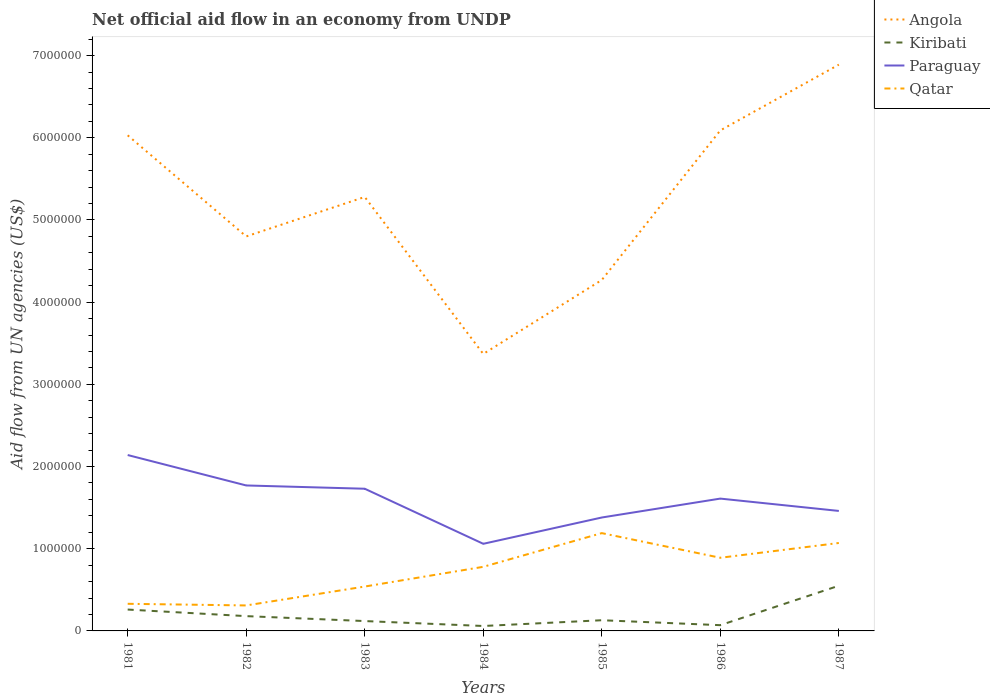Does the line corresponding to Qatar intersect with the line corresponding to Paraguay?
Provide a short and direct response. No. Across all years, what is the maximum net official aid flow in Angola?
Offer a very short reply. 3.37e+06. In which year was the net official aid flow in Qatar maximum?
Keep it short and to the point. 1982. What is the total net official aid flow in Qatar in the graph?
Your answer should be compact. -1.10e+05. What is the difference between the highest and the second highest net official aid flow in Paraguay?
Keep it short and to the point. 1.08e+06. Is the net official aid flow in Paraguay strictly greater than the net official aid flow in Kiribati over the years?
Your response must be concise. No. How many lines are there?
Offer a very short reply. 4. How many years are there in the graph?
Keep it short and to the point. 7. What is the difference between two consecutive major ticks on the Y-axis?
Ensure brevity in your answer.  1.00e+06. Does the graph contain any zero values?
Your answer should be very brief. No. What is the title of the graph?
Your answer should be compact. Net official aid flow in an economy from UNDP. Does "San Marino" appear as one of the legend labels in the graph?
Make the answer very short. No. What is the label or title of the Y-axis?
Provide a succinct answer. Aid flow from UN agencies (US$). What is the Aid flow from UN agencies (US$) of Angola in 1981?
Provide a short and direct response. 6.03e+06. What is the Aid flow from UN agencies (US$) in Paraguay in 1981?
Your answer should be compact. 2.14e+06. What is the Aid flow from UN agencies (US$) of Qatar in 1981?
Your answer should be very brief. 3.30e+05. What is the Aid flow from UN agencies (US$) of Angola in 1982?
Provide a succinct answer. 4.80e+06. What is the Aid flow from UN agencies (US$) in Kiribati in 1982?
Give a very brief answer. 1.80e+05. What is the Aid flow from UN agencies (US$) of Paraguay in 1982?
Your answer should be compact. 1.77e+06. What is the Aid flow from UN agencies (US$) of Angola in 1983?
Offer a terse response. 5.28e+06. What is the Aid flow from UN agencies (US$) in Paraguay in 1983?
Offer a very short reply. 1.73e+06. What is the Aid flow from UN agencies (US$) in Qatar in 1983?
Give a very brief answer. 5.40e+05. What is the Aid flow from UN agencies (US$) in Angola in 1984?
Ensure brevity in your answer.  3.37e+06. What is the Aid flow from UN agencies (US$) of Kiribati in 1984?
Give a very brief answer. 6.00e+04. What is the Aid flow from UN agencies (US$) of Paraguay in 1984?
Ensure brevity in your answer.  1.06e+06. What is the Aid flow from UN agencies (US$) in Qatar in 1984?
Give a very brief answer. 7.80e+05. What is the Aid flow from UN agencies (US$) of Angola in 1985?
Provide a succinct answer. 4.27e+06. What is the Aid flow from UN agencies (US$) of Kiribati in 1985?
Your answer should be very brief. 1.30e+05. What is the Aid flow from UN agencies (US$) in Paraguay in 1985?
Offer a terse response. 1.38e+06. What is the Aid flow from UN agencies (US$) in Qatar in 1985?
Offer a terse response. 1.19e+06. What is the Aid flow from UN agencies (US$) in Angola in 1986?
Give a very brief answer. 6.09e+06. What is the Aid flow from UN agencies (US$) of Kiribati in 1986?
Offer a very short reply. 7.00e+04. What is the Aid flow from UN agencies (US$) of Paraguay in 1986?
Your answer should be compact. 1.61e+06. What is the Aid flow from UN agencies (US$) in Qatar in 1986?
Provide a short and direct response. 8.90e+05. What is the Aid flow from UN agencies (US$) in Angola in 1987?
Ensure brevity in your answer.  6.89e+06. What is the Aid flow from UN agencies (US$) of Kiribati in 1987?
Offer a terse response. 5.50e+05. What is the Aid flow from UN agencies (US$) in Paraguay in 1987?
Keep it short and to the point. 1.46e+06. What is the Aid flow from UN agencies (US$) in Qatar in 1987?
Your answer should be very brief. 1.07e+06. Across all years, what is the maximum Aid flow from UN agencies (US$) in Angola?
Your response must be concise. 6.89e+06. Across all years, what is the maximum Aid flow from UN agencies (US$) of Paraguay?
Offer a terse response. 2.14e+06. Across all years, what is the maximum Aid flow from UN agencies (US$) of Qatar?
Offer a terse response. 1.19e+06. Across all years, what is the minimum Aid flow from UN agencies (US$) of Angola?
Provide a short and direct response. 3.37e+06. Across all years, what is the minimum Aid flow from UN agencies (US$) of Kiribati?
Your answer should be very brief. 6.00e+04. Across all years, what is the minimum Aid flow from UN agencies (US$) in Paraguay?
Keep it short and to the point. 1.06e+06. What is the total Aid flow from UN agencies (US$) in Angola in the graph?
Make the answer very short. 3.67e+07. What is the total Aid flow from UN agencies (US$) of Kiribati in the graph?
Offer a terse response. 1.37e+06. What is the total Aid flow from UN agencies (US$) of Paraguay in the graph?
Give a very brief answer. 1.12e+07. What is the total Aid flow from UN agencies (US$) of Qatar in the graph?
Make the answer very short. 5.11e+06. What is the difference between the Aid flow from UN agencies (US$) of Angola in 1981 and that in 1982?
Provide a succinct answer. 1.23e+06. What is the difference between the Aid flow from UN agencies (US$) in Angola in 1981 and that in 1983?
Keep it short and to the point. 7.50e+05. What is the difference between the Aid flow from UN agencies (US$) of Paraguay in 1981 and that in 1983?
Offer a very short reply. 4.10e+05. What is the difference between the Aid flow from UN agencies (US$) of Qatar in 1981 and that in 1983?
Provide a short and direct response. -2.10e+05. What is the difference between the Aid flow from UN agencies (US$) of Angola in 1981 and that in 1984?
Offer a terse response. 2.66e+06. What is the difference between the Aid flow from UN agencies (US$) in Paraguay in 1981 and that in 1984?
Provide a short and direct response. 1.08e+06. What is the difference between the Aid flow from UN agencies (US$) in Qatar in 1981 and that in 1984?
Your answer should be compact. -4.50e+05. What is the difference between the Aid flow from UN agencies (US$) in Angola in 1981 and that in 1985?
Your response must be concise. 1.76e+06. What is the difference between the Aid flow from UN agencies (US$) in Kiribati in 1981 and that in 1985?
Make the answer very short. 1.30e+05. What is the difference between the Aid flow from UN agencies (US$) of Paraguay in 1981 and that in 1985?
Your response must be concise. 7.60e+05. What is the difference between the Aid flow from UN agencies (US$) of Qatar in 1981 and that in 1985?
Your answer should be compact. -8.60e+05. What is the difference between the Aid flow from UN agencies (US$) in Angola in 1981 and that in 1986?
Ensure brevity in your answer.  -6.00e+04. What is the difference between the Aid flow from UN agencies (US$) in Kiribati in 1981 and that in 1986?
Ensure brevity in your answer.  1.90e+05. What is the difference between the Aid flow from UN agencies (US$) in Paraguay in 1981 and that in 1986?
Make the answer very short. 5.30e+05. What is the difference between the Aid flow from UN agencies (US$) of Qatar in 1981 and that in 1986?
Keep it short and to the point. -5.60e+05. What is the difference between the Aid flow from UN agencies (US$) of Angola in 1981 and that in 1987?
Ensure brevity in your answer.  -8.60e+05. What is the difference between the Aid flow from UN agencies (US$) of Kiribati in 1981 and that in 1987?
Provide a succinct answer. -2.90e+05. What is the difference between the Aid flow from UN agencies (US$) in Paraguay in 1981 and that in 1987?
Offer a terse response. 6.80e+05. What is the difference between the Aid flow from UN agencies (US$) in Qatar in 1981 and that in 1987?
Give a very brief answer. -7.40e+05. What is the difference between the Aid flow from UN agencies (US$) in Angola in 1982 and that in 1983?
Keep it short and to the point. -4.80e+05. What is the difference between the Aid flow from UN agencies (US$) of Paraguay in 1982 and that in 1983?
Make the answer very short. 4.00e+04. What is the difference between the Aid flow from UN agencies (US$) in Qatar in 1982 and that in 1983?
Offer a very short reply. -2.30e+05. What is the difference between the Aid flow from UN agencies (US$) of Angola in 1982 and that in 1984?
Keep it short and to the point. 1.43e+06. What is the difference between the Aid flow from UN agencies (US$) in Kiribati in 1982 and that in 1984?
Your answer should be very brief. 1.20e+05. What is the difference between the Aid flow from UN agencies (US$) of Paraguay in 1982 and that in 1984?
Offer a very short reply. 7.10e+05. What is the difference between the Aid flow from UN agencies (US$) in Qatar in 1982 and that in 1984?
Ensure brevity in your answer.  -4.70e+05. What is the difference between the Aid flow from UN agencies (US$) of Angola in 1982 and that in 1985?
Keep it short and to the point. 5.30e+05. What is the difference between the Aid flow from UN agencies (US$) of Qatar in 1982 and that in 1985?
Your answer should be very brief. -8.80e+05. What is the difference between the Aid flow from UN agencies (US$) of Angola in 1982 and that in 1986?
Your response must be concise. -1.29e+06. What is the difference between the Aid flow from UN agencies (US$) in Kiribati in 1982 and that in 1986?
Provide a short and direct response. 1.10e+05. What is the difference between the Aid flow from UN agencies (US$) of Qatar in 1982 and that in 1986?
Your answer should be compact. -5.80e+05. What is the difference between the Aid flow from UN agencies (US$) of Angola in 1982 and that in 1987?
Give a very brief answer. -2.09e+06. What is the difference between the Aid flow from UN agencies (US$) of Kiribati in 1982 and that in 1987?
Ensure brevity in your answer.  -3.70e+05. What is the difference between the Aid flow from UN agencies (US$) in Paraguay in 1982 and that in 1987?
Your answer should be compact. 3.10e+05. What is the difference between the Aid flow from UN agencies (US$) in Qatar in 1982 and that in 1987?
Make the answer very short. -7.60e+05. What is the difference between the Aid flow from UN agencies (US$) in Angola in 1983 and that in 1984?
Keep it short and to the point. 1.91e+06. What is the difference between the Aid flow from UN agencies (US$) in Paraguay in 1983 and that in 1984?
Your answer should be very brief. 6.70e+05. What is the difference between the Aid flow from UN agencies (US$) of Angola in 1983 and that in 1985?
Your answer should be compact. 1.01e+06. What is the difference between the Aid flow from UN agencies (US$) in Paraguay in 1983 and that in 1985?
Offer a terse response. 3.50e+05. What is the difference between the Aid flow from UN agencies (US$) of Qatar in 1983 and that in 1985?
Ensure brevity in your answer.  -6.50e+05. What is the difference between the Aid flow from UN agencies (US$) of Angola in 1983 and that in 1986?
Provide a succinct answer. -8.10e+05. What is the difference between the Aid flow from UN agencies (US$) in Kiribati in 1983 and that in 1986?
Make the answer very short. 5.00e+04. What is the difference between the Aid flow from UN agencies (US$) in Paraguay in 1983 and that in 1986?
Your answer should be very brief. 1.20e+05. What is the difference between the Aid flow from UN agencies (US$) in Qatar in 1983 and that in 1986?
Your answer should be compact. -3.50e+05. What is the difference between the Aid flow from UN agencies (US$) in Angola in 1983 and that in 1987?
Ensure brevity in your answer.  -1.61e+06. What is the difference between the Aid flow from UN agencies (US$) in Kiribati in 1983 and that in 1987?
Make the answer very short. -4.30e+05. What is the difference between the Aid flow from UN agencies (US$) of Qatar in 1983 and that in 1987?
Provide a succinct answer. -5.30e+05. What is the difference between the Aid flow from UN agencies (US$) in Angola in 1984 and that in 1985?
Give a very brief answer. -9.00e+05. What is the difference between the Aid flow from UN agencies (US$) in Kiribati in 1984 and that in 1985?
Offer a terse response. -7.00e+04. What is the difference between the Aid flow from UN agencies (US$) of Paraguay in 1984 and that in 1985?
Your response must be concise. -3.20e+05. What is the difference between the Aid flow from UN agencies (US$) in Qatar in 1984 and that in 1985?
Your answer should be very brief. -4.10e+05. What is the difference between the Aid flow from UN agencies (US$) in Angola in 1984 and that in 1986?
Ensure brevity in your answer.  -2.72e+06. What is the difference between the Aid flow from UN agencies (US$) in Kiribati in 1984 and that in 1986?
Your answer should be compact. -10000. What is the difference between the Aid flow from UN agencies (US$) of Paraguay in 1984 and that in 1986?
Provide a succinct answer. -5.50e+05. What is the difference between the Aid flow from UN agencies (US$) in Qatar in 1984 and that in 1986?
Offer a terse response. -1.10e+05. What is the difference between the Aid flow from UN agencies (US$) of Angola in 1984 and that in 1987?
Your answer should be compact. -3.52e+06. What is the difference between the Aid flow from UN agencies (US$) of Kiribati in 1984 and that in 1987?
Your answer should be compact. -4.90e+05. What is the difference between the Aid flow from UN agencies (US$) of Paraguay in 1984 and that in 1987?
Make the answer very short. -4.00e+05. What is the difference between the Aid flow from UN agencies (US$) in Qatar in 1984 and that in 1987?
Offer a very short reply. -2.90e+05. What is the difference between the Aid flow from UN agencies (US$) of Angola in 1985 and that in 1986?
Provide a short and direct response. -1.82e+06. What is the difference between the Aid flow from UN agencies (US$) in Angola in 1985 and that in 1987?
Your response must be concise. -2.62e+06. What is the difference between the Aid flow from UN agencies (US$) in Kiribati in 1985 and that in 1987?
Keep it short and to the point. -4.20e+05. What is the difference between the Aid flow from UN agencies (US$) of Paraguay in 1985 and that in 1987?
Offer a terse response. -8.00e+04. What is the difference between the Aid flow from UN agencies (US$) in Angola in 1986 and that in 1987?
Offer a very short reply. -8.00e+05. What is the difference between the Aid flow from UN agencies (US$) in Kiribati in 1986 and that in 1987?
Keep it short and to the point. -4.80e+05. What is the difference between the Aid flow from UN agencies (US$) of Angola in 1981 and the Aid flow from UN agencies (US$) of Kiribati in 1982?
Keep it short and to the point. 5.85e+06. What is the difference between the Aid flow from UN agencies (US$) of Angola in 1981 and the Aid flow from UN agencies (US$) of Paraguay in 1982?
Offer a terse response. 4.26e+06. What is the difference between the Aid flow from UN agencies (US$) in Angola in 1981 and the Aid flow from UN agencies (US$) in Qatar in 1982?
Keep it short and to the point. 5.72e+06. What is the difference between the Aid flow from UN agencies (US$) of Kiribati in 1981 and the Aid flow from UN agencies (US$) of Paraguay in 1982?
Your response must be concise. -1.51e+06. What is the difference between the Aid flow from UN agencies (US$) of Kiribati in 1981 and the Aid flow from UN agencies (US$) of Qatar in 1982?
Keep it short and to the point. -5.00e+04. What is the difference between the Aid flow from UN agencies (US$) in Paraguay in 1981 and the Aid flow from UN agencies (US$) in Qatar in 1982?
Offer a very short reply. 1.83e+06. What is the difference between the Aid flow from UN agencies (US$) in Angola in 1981 and the Aid flow from UN agencies (US$) in Kiribati in 1983?
Give a very brief answer. 5.91e+06. What is the difference between the Aid flow from UN agencies (US$) of Angola in 1981 and the Aid flow from UN agencies (US$) of Paraguay in 1983?
Keep it short and to the point. 4.30e+06. What is the difference between the Aid flow from UN agencies (US$) of Angola in 1981 and the Aid flow from UN agencies (US$) of Qatar in 1983?
Ensure brevity in your answer.  5.49e+06. What is the difference between the Aid flow from UN agencies (US$) of Kiribati in 1981 and the Aid flow from UN agencies (US$) of Paraguay in 1983?
Your answer should be very brief. -1.47e+06. What is the difference between the Aid flow from UN agencies (US$) of Kiribati in 1981 and the Aid flow from UN agencies (US$) of Qatar in 1983?
Provide a succinct answer. -2.80e+05. What is the difference between the Aid flow from UN agencies (US$) in Paraguay in 1981 and the Aid flow from UN agencies (US$) in Qatar in 1983?
Your answer should be compact. 1.60e+06. What is the difference between the Aid flow from UN agencies (US$) in Angola in 1981 and the Aid flow from UN agencies (US$) in Kiribati in 1984?
Your answer should be compact. 5.97e+06. What is the difference between the Aid flow from UN agencies (US$) of Angola in 1981 and the Aid flow from UN agencies (US$) of Paraguay in 1984?
Your answer should be very brief. 4.97e+06. What is the difference between the Aid flow from UN agencies (US$) of Angola in 1981 and the Aid flow from UN agencies (US$) of Qatar in 1984?
Make the answer very short. 5.25e+06. What is the difference between the Aid flow from UN agencies (US$) of Kiribati in 1981 and the Aid flow from UN agencies (US$) of Paraguay in 1984?
Keep it short and to the point. -8.00e+05. What is the difference between the Aid flow from UN agencies (US$) of Kiribati in 1981 and the Aid flow from UN agencies (US$) of Qatar in 1984?
Ensure brevity in your answer.  -5.20e+05. What is the difference between the Aid flow from UN agencies (US$) in Paraguay in 1981 and the Aid flow from UN agencies (US$) in Qatar in 1984?
Your answer should be very brief. 1.36e+06. What is the difference between the Aid flow from UN agencies (US$) in Angola in 1981 and the Aid flow from UN agencies (US$) in Kiribati in 1985?
Your answer should be very brief. 5.90e+06. What is the difference between the Aid flow from UN agencies (US$) of Angola in 1981 and the Aid flow from UN agencies (US$) of Paraguay in 1985?
Provide a short and direct response. 4.65e+06. What is the difference between the Aid flow from UN agencies (US$) in Angola in 1981 and the Aid flow from UN agencies (US$) in Qatar in 1985?
Your response must be concise. 4.84e+06. What is the difference between the Aid flow from UN agencies (US$) of Kiribati in 1981 and the Aid flow from UN agencies (US$) of Paraguay in 1985?
Offer a terse response. -1.12e+06. What is the difference between the Aid flow from UN agencies (US$) of Kiribati in 1981 and the Aid flow from UN agencies (US$) of Qatar in 1985?
Offer a very short reply. -9.30e+05. What is the difference between the Aid flow from UN agencies (US$) of Paraguay in 1981 and the Aid flow from UN agencies (US$) of Qatar in 1985?
Your answer should be very brief. 9.50e+05. What is the difference between the Aid flow from UN agencies (US$) of Angola in 1981 and the Aid flow from UN agencies (US$) of Kiribati in 1986?
Your answer should be compact. 5.96e+06. What is the difference between the Aid flow from UN agencies (US$) in Angola in 1981 and the Aid flow from UN agencies (US$) in Paraguay in 1986?
Provide a succinct answer. 4.42e+06. What is the difference between the Aid flow from UN agencies (US$) of Angola in 1981 and the Aid flow from UN agencies (US$) of Qatar in 1986?
Provide a short and direct response. 5.14e+06. What is the difference between the Aid flow from UN agencies (US$) in Kiribati in 1981 and the Aid flow from UN agencies (US$) in Paraguay in 1986?
Your answer should be very brief. -1.35e+06. What is the difference between the Aid flow from UN agencies (US$) of Kiribati in 1981 and the Aid flow from UN agencies (US$) of Qatar in 1986?
Make the answer very short. -6.30e+05. What is the difference between the Aid flow from UN agencies (US$) in Paraguay in 1981 and the Aid flow from UN agencies (US$) in Qatar in 1986?
Provide a short and direct response. 1.25e+06. What is the difference between the Aid flow from UN agencies (US$) in Angola in 1981 and the Aid flow from UN agencies (US$) in Kiribati in 1987?
Your answer should be compact. 5.48e+06. What is the difference between the Aid flow from UN agencies (US$) in Angola in 1981 and the Aid flow from UN agencies (US$) in Paraguay in 1987?
Provide a short and direct response. 4.57e+06. What is the difference between the Aid flow from UN agencies (US$) of Angola in 1981 and the Aid flow from UN agencies (US$) of Qatar in 1987?
Give a very brief answer. 4.96e+06. What is the difference between the Aid flow from UN agencies (US$) in Kiribati in 1981 and the Aid flow from UN agencies (US$) in Paraguay in 1987?
Offer a terse response. -1.20e+06. What is the difference between the Aid flow from UN agencies (US$) in Kiribati in 1981 and the Aid flow from UN agencies (US$) in Qatar in 1987?
Offer a terse response. -8.10e+05. What is the difference between the Aid flow from UN agencies (US$) of Paraguay in 1981 and the Aid flow from UN agencies (US$) of Qatar in 1987?
Offer a very short reply. 1.07e+06. What is the difference between the Aid flow from UN agencies (US$) of Angola in 1982 and the Aid flow from UN agencies (US$) of Kiribati in 1983?
Offer a terse response. 4.68e+06. What is the difference between the Aid flow from UN agencies (US$) of Angola in 1982 and the Aid flow from UN agencies (US$) of Paraguay in 1983?
Your answer should be compact. 3.07e+06. What is the difference between the Aid flow from UN agencies (US$) of Angola in 1982 and the Aid flow from UN agencies (US$) of Qatar in 1983?
Provide a succinct answer. 4.26e+06. What is the difference between the Aid flow from UN agencies (US$) in Kiribati in 1982 and the Aid flow from UN agencies (US$) in Paraguay in 1983?
Ensure brevity in your answer.  -1.55e+06. What is the difference between the Aid flow from UN agencies (US$) of Kiribati in 1982 and the Aid flow from UN agencies (US$) of Qatar in 1983?
Provide a succinct answer. -3.60e+05. What is the difference between the Aid flow from UN agencies (US$) of Paraguay in 1982 and the Aid flow from UN agencies (US$) of Qatar in 1983?
Ensure brevity in your answer.  1.23e+06. What is the difference between the Aid flow from UN agencies (US$) in Angola in 1982 and the Aid flow from UN agencies (US$) in Kiribati in 1984?
Provide a short and direct response. 4.74e+06. What is the difference between the Aid flow from UN agencies (US$) in Angola in 1982 and the Aid flow from UN agencies (US$) in Paraguay in 1984?
Your answer should be very brief. 3.74e+06. What is the difference between the Aid flow from UN agencies (US$) of Angola in 1982 and the Aid flow from UN agencies (US$) of Qatar in 1984?
Make the answer very short. 4.02e+06. What is the difference between the Aid flow from UN agencies (US$) of Kiribati in 1982 and the Aid flow from UN agencies (US$) of Paraguay in 1984?
Offer a terse response. -8.80e+05. What is the difference between the Aid flow from UN agencies (US$) in Kiribati in 1982 and the Aid flow from UN agencies (US$) in Qatar in 1984?
Provide a succinct answer. -6.00e+05. What is the difference between the Aid flow from UN agencies (US$) of Paraguay in 1982 and the Aid flow from UN agencies (US$) of Qatar in 1984?
Keep it short and to the point. 9.90e+05. What is the difference between the Aid flow from UN agencies (US$) of Angola in 1982 and the Aid flow from UN agencies (US$) of Kiribati in 1985?
Offer a very short reply. 4.67e+06. What is the difference between the Aid flow from UN agencies (US$) in Angola in 1982 and the Aid flow from UN agencies (US$) in Paraguay in 1985?
Provide a short and direct response. 3.42e+06. What is the difference between the Aid flow from UN agencies (US$) in Angola in 1982 and the Aid flow from UN agencies (US$) in Qatar in 1985?
Give a very brief answer. 3.61e+06. What is the difference between the Aid flow from UN agencies (US$) in Kiribati in 1982 and the Aid flow from UN agencies (US$) in Paraguay in 1985?
Offer a very short reply. -1.20e+06. What is the difference between the Aid flow from UN agencies (US$) in Kiribati in 1982 and the Aid flow from UN agencies (US$) in Qatar in 1985?
Your answer should be compact. -1.01e+06. What is the difference between the Aid flow from UN agencies (US$) of Paraguay in 1982 and the Aid flow from UN agencies (US$) of Qatar in 1985?
Your response must be concise. 5.80e+05. What is the difference between the Aid flow from UN agencies (US$) in Angola in 1982 and the Aid flow from UN agencies (US$) in Kiribati in 1986?
Give a very brief answer. 4.73e+06. What is the difference between the Aid flow from UN agencies (US$) of Angola in 1982 and the Aid flow from UN agencies (US$) of Paraguay in 1986?
Keep it short and to the point. 3.19e+06. What is the difference between the Aid flow from UN agencies (US$) in Angola in 1982 and the Aid flow from UN agencies (US$) in Qatar in 1986?
Your response must be concise. 3.91e+06. What is the difference between the Aid flow from UN agencies (US$) in Kiribati in 1982 and the Aid flow from UN agencies (US$) in Paraguay in 1986?
Provide a short and direct response. -1.43e+06. What is the difference between the Aid flow from UN agencies (US$) of Kiribati in 1982 and the Aid flow from UN agencies (US$) of Qatar in 1986?
Offer a terse response. -7.10e+05. What is the difference between the Aid flow from UN agencies (US$) in Paraguay in 1982 and the Aid flow from UN agencies (US$) in Qatar in 1986?
Ensure brevity in your answer.  8.80e+05. What is the difference between the Aid flow from UN agencies (US$) in Angola in 1982 and the Aid flow from UN agencies (US$) in Kiribati in 1987?
Keep it short and to the point. 4.25e+06. What is the difference between the Aid flow from UN agencies (US$) in Angola in 1982 and the Aid flow from UN agencies (US$) in Paraguay in 1987?
Your response must be concise. 3.34e+06. What is the difference between the Aid flow from UN agencies (US$) of Angola in 1982 and the Aid flow from UN agencies (US$) of Qatar in 1987?
Provide a succinct answer. 3.73e+06. What is the difference between the Aid flow from UN agencies (US$) in Kiribati in 1982 and the Aid flow from UN agencies (US$) in Paraguay in 1987?
Offer a very short reply. -1.28e+06. What is the difference between the Aid flow from UN agencies (US$) of Kiribati in 1982 and the Aid flow from UN agencies (US$) of Qatar in 1987?
Ensure brevity in your answer.  -8.90e+05. What is the difference between the Aid flow from UN agencies (US$) in Angola in 1983 and the Aid flow from UN agencies (US$) in Kiribati in 1984?
Give a very brief answer. 5.22e+06. What is the difference between the Aid flow from UN agencies (US$) of Angola in 1983 and the Aid flow from UN agencies (US$) of Paraguay in 1984?
Provide a succinct answer. 4.22e+06. What is the difference between the Aid flow from UN agencies (US$) in Angola in 1983 and the Aid flow from UN agencies (US$) in Qatar in 1984?
Provide a succinct answer. 4.50e+06. What is the difference between the Aid flow from UN agencies (US$) of Kiribati in 1983 and the Aid flow from UN agencies (US$) of Paraguay in 1984?
Provide a short and direct response. -9.40e+05. What is the difference between the Aid flow from UN agencies (US$) in Kiribati in 1983 and the Aid flow from UN agencies (US$) in Qatar in 1984?
Ensure brevity in your answer.  -6.60e+05. What is the difference between the Aid flow from UN agencies (US$) of Paraguay in 1983 and the Aid flow from UN agencies (US$) of Qatar in 1984?
Give a very brief answer. 9.50e+05. What is the difference between the Aid flow from UN agencies (US$) of Angola in 1983 and the Aid flow from UN agencies (US$) of Kiribati in 1985?
Offer a very short reply. 5.15e+06. What is the difference between the Aid flow from UN agencies (US$) of Angola in 1983 and the Aid flow from UN agencies (US$) of Paraguay in 1985?
Offer a very short reply. 3.90e+06. What is the difference between the Aid flow from UN agencies (US$) in Angola in 1983 and the Aid flow from UN agencies (US$) in Qatar in 1985?
Offer a terse response. 4.09e+06. What is the difference between the Aid flow from UN agencies (US$) of Kiribati in 1983 and the Aid flow from UN agencies (US$) of Paraguay in 1985?
Your answer should be compact. -1.26e+06. What is the difference between the Aid flow from UN agencies (US$) of Kiribati in 1983 and the Aid flow from UN agencies (US$) of Qatar in 1985?
Your response must be concise. -1.07e+06. What is the difference between the Aid flow from UN agencies (US$) in Paraguay in 1983 and the Aid flow from UN agencies (US$) in Qatar in 1985?
Provide a succinct answer. 5.40e+05. What is the difference between the Aid flow from UN agencies (US$) in Angola in 1983 and the Aid flow from UN agencies (US$) in Kiribati in 1986?
Provide a succinct answer. 5.21e+06. What is the difference between the Aid flow from UN agencies (US$) of Angola in 1983 and the Aid flow from UN agencies (US$) of Paraguay in 1986?
Make the answer very short. 3.67e+06. What is the difference between the Aid flow from UN agencies (US$) of Angola in 1983 and the Aid flow from UN agencies (US$) of Qatar in 1986?
Your answer should be compact. 4.39e+06. What is the difference between the Aid flow from UN agencies (US$) in Kiribati in 1983 and the Aid flow from UN agencies (US$) in Paraguay in 1986?
Your answer should be compact. -1.49e+06. What is the difference between the Aid flow from UN agencies (US$) of Kiribati in 1983 and the Aid flow from UN agencies (US$) of Qatar in 1986?
Offer a terse response. -7.70e+05. What is the difference between the Aid flow from UN agencies (US$) in Paraguay in 1983 and the Aid flow from UN agencies (US$) in Qatar in 1986?
Keep it short and to the point. 8.40e+05. What is the difference between the Aid flow from UN agencies (US$) in Angola in 1983 and the Aid flow from UN agencies (US$) in Kiribati in 1987?
Your response must be concise. 4.73e+06. What is the difference between the Aid flow from UN agencies (US$) of Angola in 1983 and the Aid flow from UN agencies (US$) of Paraguay in 1987?
Give a very brief answer. 3.82e+06. What is the difference between the Aid flow from UN agencies (US$) of Angola in 1983 and the Aid flow from UN agencies (US$) of Qatar in 1987?
Offer a very short reply. 4.21e+06. What is the difference between the Aid flow from UN agencies (US$) in Kiribati in 1983 and the Aid flow from UN agencies (US$) in Paraguay in 1987?
Give a very brief answer. -1.34e+06. What is the difference between the Aid flow from UN agencies (US$) of Kiribati in 1983 and the Aid flow from UN agencies (US$) of Qatar in 1987?
Ensure brevity in your answer.  -9.50e+05. What is the difference between the Aid flow from UN agencies (US$) in Paraguay in 1983 and the Aid flow from UN agencies (US$) in Qatar in 1987?
Keep it short and to the point. 6.60e+05. What is the difference between the Aid flow from UN agencies (US$) of Angola in 1984 and the Aid flow from UN agencies (US$) of Kiribati in 1985?
Your response must be concise. 3.24e+06. What is the difference between the Aid flow from UN agencies (US$) of Angola in 1984 and the Aid flow from UN agencies (US$) of Paraguay in 1985?
Provide a succinct answer. 1.99e+06. What is the difference between the Aid flow from UN agencies (US$) in Angola in 1984 and the Aid flow from UN agencies (US$) in Qatar in 1985?
Offer a very short reply. 2.18e+06. What is the difference between the Aid flow from UN agencies (US$) of Kiribati in 1984 and the Aid flow from UN agencies (US$) of Paraguay in 1985?
Provide a short and direct response. -1.32e+06. What is the difference between the Aid flow from UN agencies (US$) in Kiribati in 1984 and the Aid flow from UN agencies (US$) in Qatar in 1985?
Provide a succinct answer. -1.13e+06. What is the difference between the Aid flow from UN agencies (US$) in Angola in 1984 and the Aid flow from UN agencies (US$) in Kiribati in 1986?
Keep it short and to the point. 3.30e+06. What is the difference between the Aid flow from UN agencies (US$) of Angola in 1984 and the Aid flow from UN agencies (US$) of Paraguay in 1986?
Provide a succinct answer. 1.76e+06. What is the difference between the Aid flow from UN agencies (US$) of Angola in 1984 and the Aid flow from UN agencies (US$) of Qatar in 1986?
Offer a very short reply. 2.48e+06. What is the difference between the Aid flow from UN agencies (US$) of Kiribati in 1984 and the Aid flow from UN agencies (US$) of Paraguay in 1986?
Your response must be concise. -1.55e+06. What is the difference between the Aid flow from UN agencies (US$) of Kiribati in 1984 and the Aid flow from UN agencies (US$) of Qatar in 1986?
Provide a short and direct response. -8.30e+05. What is the difference between the Aid flow from UN agencies (US$) of Angola in 1984 and the Aid flow from UN agencies (US$) of Kiribati in 1987?
Ensure brevity in your answer.  2.82e+06. What is the difference between the Aid flow from UN agencies (US$) of Angola in 1984 and the Aid flow from UN agencies (US$) of Paraguay in 1987?
Offer a very short reply. 1.91e+06. What is the difference between the Aid flow from UN agencies (US$) in Angola in 1984 and the Aid flow from UN agencies (US$) in Qatar in 1987?
Your response must be concise. 2.30e+06. What is the difference between the Aid flow from UN agencies (US$) in Kiribati in 1984 and the Aid flow from UN agencies (US$) in Paraguay in 1987?
Make the answer very short. -1.40e+06. What is the difference between the Aid flow from UN agencies (US$) of Kiribati in 1984 and the Aid flow from UN agencies (US$) of Qatar in 1987?
Provide a succinct answer. -1.01e+06. What is the difference between the Aid flow from UN agencies (US$) in Paraguay in 1984 and the Aid flow from UN agencies (US$) in Qatar in 1987?
Give a very brief answer. -10000. What is the difference between the Aid flow from UN agencies (US$) in Angola in 1985 and the Aid flow from UN agencies (US$) in Kiribati in 1986?
Keep it short and to the point. 4.20e+06. What is the difference between the Aid flow from UN agencies (US$) of Angola in 1985 and the Aid flow from UN agencies (US$) of Paraguay in 1986?
Your answer should be very brief. 2.66e+06. What is the difference between the Aid flow from UN agencies (US$) in Angola in 1985 and the Aid flow from UN agencies (US$) in Qatar in 1986?
Your response must be concise. 3.38e+06. What is the difference between the Aid flow from UN agencies (US$) in Kiribati in 1985 and the Aid flow from UN agencies (US$) in Paraguay in 1986?
Your response must be concise. -1.48e+06. What is the difference between the Aid flow from UN agencies (US$) in Kiribati in 1985 and the Aid flow from UN agencies (US$) in Qatar in 1986?
Your answer should be compact. -7.60e+05. What is the difference between the Aid flow from UN agencies (US$) of Paraguay in 1985 and the Aid flow from UN agencies (US$) of Qatar in 1986?
Provide a short and direct response. 4.90e+05. What is the difference between the Aid flow from UN agencies (US$) of Angola in 1985 and the Aid flow from UN agencies (US$) of Kiribati in 1987?
Provide a succinct answer. 3.72e+06. What is the difference between the Aid flow from UN agencies (US$) in Angola in 1985 and the Aid flow from UN agencies (US$) in Paraguay in 1987?
Offer a very short reply. 2.81e+06. What is the difference between the Aid flow from UN agencies (US$) of Angola in 1985 and the Aid flow from UN agencies (US$) of Qatar in 1987?
Your response must be concise. 3.20e+06. What is the difference between the Aid flow from UN agencies (US$) of Kiribati in 1985 and the Aid flow from UN agencies (US$) of Paraguay in 1987?
Your answer should be compact. -1.33e+06. What is the difference between the Aid flow from UN agencies (US$) of Kiribati in 1985 and the Aid flow from UN agencies (US$) of Qatar in 1987?
Keep it short and to the point. -9.40e+05. What is the difference between the Aid flow from UN agencies (US$) of Paraguay in 1985 and the Aid flow from UN agencies (US$) of Qatar in 1987?
Keep it short and to the point. 3.10e+05. What is the difference between the Aid flow from UN agencies (US$) of Angola in 1986 and the Aid flow from UN agencies (US$) of Kiribati in 1987?
Your response must be concise. 5.54e+06. What is the difference between the Aid flow from UN agencies (US$) in Angola in 1986 and the Aid flow from UN agencies (US$) in Paraguay in 1987?
Keep it short and to the point. 4.63e+06. What is the difference between the Aid flow from UN agencies (US$) of Angola in 1986 and the Aid flow from UN agencies (US$) of Qatar in 1987?
Provide a short and direct response. 5.02e+06. What is the difference between the Aid flow from UN agencies (US$) of Kiribati in 1986 and the Aid flow from UN agencies (US$) of Paraguay in 1987?
Your answer should be compact. -1.39e+06. What is the difference between the Aid flow from UN agencies (US$) of Paraguay in 1986 and the Aid flow from UN agencies (US$) of Qatar in 1987?
Keep it short and to the point. 5.40e+05. What is the average Aid flow from UN agencies (US$) in Angola per year?
Your response must be concise. 5.25e+06. What is the average Aid flow from UN agencies (US$) of Kiribati per year?
Your answer should be compact. 1.96e+05. What is the average Aid flow from UN agencies (US$) of Paraguay per year?
Your answer should be very brief. 1.59e+06. What is the average Aid flow from UN agencies (US$) in Qatar per year?
Give a very brief answer. 7.30e+05. In the year 1981, what is the difference between the Aid flow from UN agencies (US$) in Angola and Aid flow from UN agencies (US$) in Kiribati?
Ensure brevity in your answer.  5.77e+06. In the year 1981, what is the difference between the Aid flow from UN agencies (US$) in Angola and Aid flow from UN agencies (US$) in Paraguay?
Your answer should be compact. 3.89e+06. In the year 1981, what is the difference between the Aid flow from UN agencies (US$) of Angola and Aid flow from UN agencies (US$) of Qatar?
Your response must be concise. 5.70e+06. In the year 1981, what is the difference between the Aid flow from UN agencies (US$) in Kiribati and Aid flow from UN agencies (US$) in Paraguay?
Provide a succinct answer. -1.88e+06. In the year 1981, what is the difference between the Aid flow from UN agencies (US$) in Paraguay and Aid flow from UN agencies (US$) in Qatar?
Provide a short and direct response. 1.81e+06. In the year 1982, what is the difference between the Aid flow from UN agencies (US$) in Angola and Aid flow from UN agencies (US$) in Kiribati?
Offer a very short reply. 4.62e+06. In the year 1982, what is the difference between the Aid flow from UN agencies (US$) in Angola and Aid flow from UN agencies (US$) in Paraguay?
Offer a terse response. 3.03e+06. In the year 1982, what is the difference between the Aid flow from UN agencies (US$) of Angola and Aid flow from UN agencies (US$) of Qatar?
Provide a short and direct response. 4.49e+06. In the year 1982, what is the difference between the Aid flow from UN agencies (US$) in Kiribati and Aid flow from UN agencies (US$) in Paraguay?
Make the answer very short. -1.59e+06. In the year 1982, what is the difference between the Aid flow from UN agencies (US$) in Kiribati and Aid flow from UN agencies (US$) in Qatar?
Make the answer very short. -1.30e+05. In the year 1982, what is the difference between the Aid flow from UN agencies (US$) of Paraguay and Aid flow from UN agencies (US$) of Qatar?
Your answer should be compact. 1.46e+06. In the year 1983, what is the difference between the Aid flow from UN agencies (US$) of Angola and Aid flow from UN agencies (US$) of Kiribati?
Make the answer very short. 5.16e+06. In the year 1983, what is the difference between the Aid flow from UN agencies (US$) in Angola and Aid flow from UN agencies (US$) in Paraguay?
Provide a short and direct response. 3.55e+06. In the year 1983, what is the difference between the Aid flow from UN agencies (US$) of Angola and Aid flow from UN agencies (US$) of Qatar?
Offer a very short reply. 4.74e+06. In the year 1983, what is the difference between the Aid flow from UN agencies (US$) of Kiribati and Aid flow from UN agencies (US$) of Paraguay?
Keep it short and to the point. -1.61e+06. In the year 1983, what is the difference between the Aid flow from UN agencies (US$) of Kiribati and Aid flow from UN agencies (US$) of Qatar?
Offer a terse response. -4.20e+05. In the year 1983, what is the difference between the Aid flow from UN agencies (US$) in Paraguay and Aid flow from UN agencies (US$) in Qatar?
Give a very brief answer. 1.19e+06. In the year 1984, what is the difference between the Aid flow from UN agencies (US$) in Angola and Aid flow from UN agencies (US$) in Kiribati?
Ensure brevity in your answer.  3.31e+06. In the year 1984, what is the difference between the Aid flow from UN agencies (US$) in Angola and Aid flow from UN agencies (US$) in Paraguay?
Provide a succinct answer. 2.31e+06. In the year 1984, what is the difference between the Aid flow from UN agencies (US$) of Angola and Aid flow from UN agencies (US$) of Qatar?
Keep it short and to the point. 2.59e+06. In the year 1984, what is the difference between the Aid flow from UN agencies (US$) of Kiribati and Aid flow from UN agencies (US$) of Qatar?
Provide a succinct answer. -7.20e+05. In the year 1984, what is the difference between the Aid flow from UN agencies (US$) in Paraguay and Aid flow from UN agencies (US$) in Qatar?
Your answer should be very brief. 2.80e+05. In the year 1985, what is the difference between the Aid flow from UN agencies (US$) of Angola and Aid flow from UN agencies (US$) of Kiribati?
Give a very brief answer. 4.14e+06. In the year 1985, what is the difference between the Aid flow from UN agencies (US$) in Angola and Aid flow from UN agencies (US$) in Paraguay?
Keep it short and to the point. 2.89e+06. In the year 1985, what is the difference between the Aid flow from UN agencies (US$) of Angola and Aid flow from UN agencies (US$) of Qatar?
Offer a terse response. 3.08e+06. In the year 1985, what is the difference between the Aid flow from UN agencies (US$) of Kiribati and Aid flow from UN agencies (US$) of Paraguay?
Give a very brief answer. -1.25e+06. In the year 1985, what is the difference between the Aid flow from UN agencies (US$) of Kiribati and Aid flow from UN agencies (US$) of Qatar?
Provide a short and direct response. -1.06e+06. In the year 1986, what is the difference between the Aid flow from UN agencies (US$) of Angola and Aid flow from UN agencies (US$) of Kiribati?
Give a very brief answer. 6.02e+06. In the year 1986, what is the difference between the Aid flow from UN agencies (US$) in Angola and Aid flow from UN agencies (US$) in Paraguay?
Your response must be concise. 4.48e+06. In the year 1986, what is the difference between the Aid flow from UN agencies (US$) in Angola and Aid flow from UN agencies (US$) in Qatar?
Give a very brief answer. 5.20e+06. In the year 1986, what is the difference between the Aid flow from UN agencies (US$) of Kiribati and Aid flow from UN agencies (US$) of Paraguay?
Ensure brevity in your answer.  -1.54e+06. In the year 1986, what is the difference between the Aid flow from UN agencies (US$) in Kiribati and Aid flow from UN agencies (US$) in Qatar?
Give a very brief answer. -8.20e+05. In the year 1986, what is the difference between the Aid flow from UN agencies (US$) of Paraguay and Aid flow from UN agencies (US$) of Qatar?
Your response must be concise. 7.20e+05. In the year 1987, what is the difference between the Aid flow from UN agencies (US$) of Angola and Aid flow from UN agencies (US$) of Kiribati?
Provide a succinct answer. 6.34e+06. In the year 1987, what is the difference between the Aid flow from UN agencies (US$) in Angola and Aid flow from UN agencies (US$) in Paraguay?
Keep it short and to the point. 5.43e+06. In the year 1987, what is the difference between the Aid flow from UN agencies (US$) of Angola and Aid flow from UN agencies (US$) of Qatar?
Your response must be concise. 5.82e+06. In the year 1987, what is the difference between the Aid flow from UN agencies (US$) of Kiribati and Aid flow from UN agencies (US$) of Paraguay?
Your answer should be compact. -9.10e+05. In the year 1987, what is the difference between the Aid flow from UN agencies (US$) of Kiribati and Aid flow from UN agencies (US$) of Qatar?
Keep it short and to the point. -5.20e+05. What is the ratio of the Aid flow from UN agencies (US$) of Angola in 1981 to that in 1982?
Give a very brief answer. 1.26. What is the ratio of the Aid flow from UN agencies (US$) in Kiribati in 1981 to that in 1982?
Give a very brief answer. 1.44. What is the ratio of the Aid flow from UN agencies (US$) of Paraguay in 1981 to that in 1982?
Provide a succinct answer. 1.21. What is the ratio of the Aid flow from UN agencies (US$) of Qatar in 1981 to that in 1982?
Your answer should be very brief. 1.06. What is the ratio of the Aid flow from UN agencies (US$) in Angola in 1981 to that in 1983?
Provide a succinct answer. 1.14. What is the ratio of the Aid flow from UN agencies (US$) in Kiribati in 1981 to that in 1983?
Keep it short and to the point. 2.17. What is the ratio of the Aid flow from UN agencies (US$) in Paraguay in 1981 to that in 1983?
Offer a terse response. 1.24. What is the ratio of the Aid flow from UN agencies (US$) of Qatar in 1981 to that in 1983?
Provide a short and direct response. 0.61. What is the ratio of the Aid flow from UN agencies (US$) of Angola in 1981 to that in 1984?
Your answer should be very brief. 1.79. What is the ratio of the Aid flow from UN agencies (US$) of Kiribati in 1981 to that in 1984?
Your answer should be compact. 4.33. What is the ratio of the Aid flow from UN agencies (US$) of Paraguay in 1981 to that in 1984?
Provide a short and direct response. 2.02. What is the ratio of the Aid flow from UN agencies (US$) in Qatar in 1981 to that in 1984?
Keep it short and to the point. 0.42. What is the ratio of the Aid flow from UN agencies (US$) of Angola in 1981 to that in 1985?
Ensure brevity in your answer.  1.41. What is the ratio of the Aid flow from UN agencies (US$) of Paraguay in 1981 to that in 1985?
Offer a terse response. 1.55. What is the ratio of the Aid flow from UN agencies (US$) in Qatar in 1981 to that in 1985?
Provide a succinct answer. 0.28. What is the ratio of the Aid flow from UN agencies (US$) of Angola in 1981 to that in 1986?
Provide a short and direct response. 0.99. What is the ratio of the Aid flow from UN agencies (US$) in Kiribati in 1981 to that in 1986?
Provide a short and direct response. 3.71. What is the ratio of the Aid flow from UN agencies (US$) of Paraguay in 1981 to that in 1986?
Keep it short and to the point. 1.33. What is the ratio of the Aid flow from UN agencies (US$) in Qatar in 1981 to that in 1986?
Keep it short and to the point. 0.37. What is the ratio of the Aid flow from UN agencies (US$) of Angola in 1981 to that in 1987?
Your response must be concise. 0.88. What is the ratio of the Aid flow from UN agencies (US$) of Kiribati in 1981 to that in 1987?
Ensure brevity in your answer.  0.47. What is the ratio of the Aid flow from UN agencies (US$) of Paraguay in 1981 to that in 1987?
Provide a short and direct response. 1.47. What is the ratio of the Aid flow from UN agencies (US$) of Qatar in 1981 to that in 1987?
Offer a very short reply. 0.31. What is the ratio of the Aid flow from UN agencies (US$) in Kiribati in 1982 to that in 1983?
Offer a very short reply. 1.5. What is the ratio of the Aid flow from UN agencies (US$) of Paraguay in 1982 to that in 1983?
Your response must be concise. 1.02. What is the ratio of the Aid flow from UN agencies (US$) of Qatar in 1982 to that in 1983?
Make the answer very short. 0.57. What is the ratio of the Aid flow from UN agencies (US$) of Angola in 1982 to that in 1984?
Your response must be concise. 1.42. What is the ratio of the Aid flow from UN agencies (US$) in Kiribati in 1982 to that in 1984?
Make the answer very short. 3. What is the ratio of the Aid flow from UN agencies (US$) of Paraguay in 1982 to that in 1984?
Your response must be concise. 1.67. What is the ratio of the Aid flow from UN agencies (US$) in Qatar in 1982 to that in 1984?
Your answer should be very brief. 0.4. What is the ratio of the Aid flow from UN agencies (US$) of Angola in 1982 to that in 1985?
Your response must be concise. 1.12. What is the ratio of the Aid flow from UN agencies (US$) of Kiribati in 1982 to that in 1985?
Provide a short and direct response. 1.38. What is the ratio of the Aid flow from UN agencies (US$) in Paraguay in 1982 to that in 1985?
Offer a terse response. 1.28. What is the ratio of the Aid flow from UN agencies (US$) in Qatar in 1982 to that in 1985?
Ensure brevity in your answer.  0.26. What is the ratio of the Aid flow from UN agencies (US$) in Angola in 1982 to that in 1986?
Offer a terse response. 0.79. What is the ratio of the Aid flow from UN agencies (US$) of Kiribati in 1982 to that in 1986?
Provide a succinct answer. 2.57. What is the ratio of the Aid flow from UN agencies (US$) of Paraguay in 1982 to that in 1986?
Your response must be concise. 1.1. What is the ratio of the Aid flow from UN agencies (US$) in Qatar in 1982 to that in 1986?
Offer a terse response. 0.35. What is the ratio of the Aid flow from UN agencies (US$) in Angola in 1982 to that in 1987?
Provide a succinct answer. 0.7. What is the ratio of the Aid flow from UN agencies (US$) of Kiribati in 1982 to that in 1987?
Make the answer very short. 0.33. What is the ratio of the Aid flow from UN agencies (US$) in Paraguay in 1982 to that in 1987?
Offer a very short reply. 1.21. What is the ratio of the Aid flow from UN agencies (US$) in Qatar in 1982 to that in 1987?
Your answer should be compact. 0.29. What is the ratio of the Aid flow from UN agencies (US$) of Angola in 1983 to that in 1984?
Make the answer very short. 1.57. What is the ratio of the Aid flow from UN agencies (US$) in Paraguay in 1983 to that in 1984?
Your answer should be very brief. 1.63. What is the ratio of the Aid flow from UN agencies (US$) of Qatar in 1983 to that in 1984?
Provide a succinct answer. 0.69. What is the ratio of the Aid flow from UN agencies (US$) in Angola in 1983 to that in 1985?
Offer a terse response. 1.24. What is the ratio of the Aid flow from UN agencies (US$) of Kiribati in 1983 to that in 1985?
Give a very brief answer. 0.92. What is the ratio of the Aid flow from UN agencies (US$) in Paraguay in 1983 to that in 1985?
Give a very brief answer. 1.25. What is the ratio of the Aid flow from UN agencies (US$) in Qatar in 1983 to that in 1985?
Ensure brevity in your answer.  0.45. What is the ratio of the Aid flow from UN agencies (US$) of Angola in 1983 to that in 1986?
Keep it short and to the point. 0.87. What is the ratio of the Aid flow from UN agencies (US$) in Kiribati in 1983 to that in 1986?
Your answer should be very brief. 1.71. What is the ratio of the Aid flow from UN agencies (US$) of Paraguay in 1983 to that in 1986?
Give a very brief answer. 1.07. What is the ratio of the Aid flow from UN agencies (US$) of Qatar in 1983 to that in 1986?
Your answer should be compact. 0.61. What is the ratio of the Aid flow from UN agencies (US$) in Angola in 1983 to that in 1987?
Provide a succinct answer. 0.77. What is the ratio of the Aid flow from UN agencies (US$) of Kiribati in 1983 to that in 1987?
Your answer should be compact. 0.22. What is the ratio of the Aid flow from UN agencies (US$) of Paraguay in 1983 to that in 1987?
Provide a short and direct response. 1.18. What is the ratio of the Aid flow from UN agencies (US$) in Qatar in 1983 to that in 1987?
Your response must be concise. 0.5. What is the ratio of the Aid flow from UN agencies (US$) in Angola in 1984 to that in 1985?
Your response must be concise. 0.79. What is the ratio of the Aid flow from UN agencies (US$) of Kiribati in 1984 to that in 1985?
Offer a terse response. 0.46. What is the ratio of the Aid flow from UN agencies (US$) in Paraguay in 1984 to that in 1985?
Provide a succinct answer. 0.77. What is the ratio of the Aid flow from UN agencies (US$) in Qatar in 1984 to that in 1985?
Provide a short and direct response. 0.66. What is the ratio of the Aid flow from UN agencies (US$) of Angola in 1984 to that in 1986?
Make the answer very short. 0.55. What is the ratio of the Aid flow from UN agencies (US$) in Kiribati in 1984 to that in 1986?
Offer a terse response. 0.86. What is the ratio of the Aid flow from UN agencies (US$) in Paraguay in 1984 to that in 1986?
Your response must be concise. 0.66. What is the ratio of the Aid flow from UN agencies (US$) of Qatar in 1984 to that in 1986?
Keep it short and to the point. 0.88. What is the ratio of the Aid flow from UN agencies (US$) in Angola in 1984 to that in 1987?
Ensure brevity in your answer.  0.49. What is the ratio of the Aid flow from UN agencies (US$) in Kiribati in 1984 to that in 1987?
Provide a short and direct response. 0.11. What is the ratio of the Aid flow from UN agencies (US$) of Paraguay in 1984 to that in 1987?
Your answer should be compact. 0.73. What is the ratio of the Aid flow from UN agencies (US$) in Qatar in 1984 to that in 1987?
Provide a short and direct response. 0.73. What is the ratio of the Aid flow from UN agencies (US$) in Angola in 1985 to that in 1986?
Provide a short and direct response. 0.7. What is the ratio of the Aid flow from UN agencies (US$) in Kiribati in 1985 to that in 1986?
Make the answer very short. 1.86. What is the ratio of the Aid flow from UN agencies (US$) of Paraguay in 1985 to that in 1986?
Make the answer very short. 0.86. What is the ratio of the Aid flow from UN agencies (US$) of Qatar in 1985 to that in 1986?
Your response must be concise. 1.34. What is the ratio of the Aid flow from UN agencies (US$) of Angola in 1985 to that in 1987?
Provide a short and direct response. 0.62. What is the ratio of the Aid flow from UN agencies (US$) in Kiribati in 1985 to that in 1987?
Your answer should be very brief. 0.24. What is the ratio of the Aid flow from UN agencies (US$) in Paraguay in 1985 to that in 1987?
Ensure brevity in your answer.  0.95. What is the ratio of the Aid flow from UN agencies (US$) of Qatar in 1985 to that in 1987?
Make the answer very short. 1.11. What is the ratio of the Aid flow from UN agencies (US$) in Angola in 1986 to that in 1987?
Your answer should be compact. 0.88. What is the ratio of the Aid flow from UN agencies (US$) of Kiribati in 1986 to that in 1987?
Your answer should be very brief. 0.13. What is the ratio of the Aid flow from UN agencies (US$) of Paraguay in 1986 to that in 1987?
Your answer should be very brief. 1.1. What is the ratio of the Aid flow from UN agencies (US$) of Qatar in 1986 to that in 1987?
Keep it short and to the point. 0.83. What is the difference between the highest and the second highest Aid flow from UN agencies (US$) in Qatar?
Offer a terse response. 1.20e+05. What is the difference between the highest and the lowest Aid flow from UN agencies (US$) in Angola?
Your response must be concise. 3.52e+06. What is the difference between the highest and the lowest Aid flow from UN agencies (US$) of Paraguay?
Offer a terse response. 1.08e+06. What is the difference between the highest and the lowest Aid flow from UN agencies (US$) in Qatar?
Offer a very short reply. 8.80e+05. 